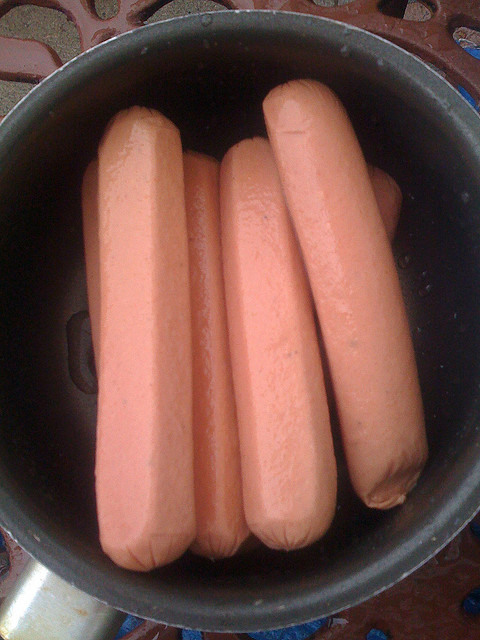What are some creative ways to serve the food in this image that might make it more appealing? To enhance the appeal of hot dogs, you could serve them in a variety of creative ways. For example, slicing them and incorporating them into a pasta dish with a robust tomato sauce and vegetables adds nutritional value and flavor complexity. Another option is creating a 'hot dog bar' where eaters can choose from a variety of healthy toppings, like fresh salsa, sauerkraut, and homemade relishes. Using whole-grain or lettuce wraps instead of traditional buns can also offer a healthier and unique twist. 